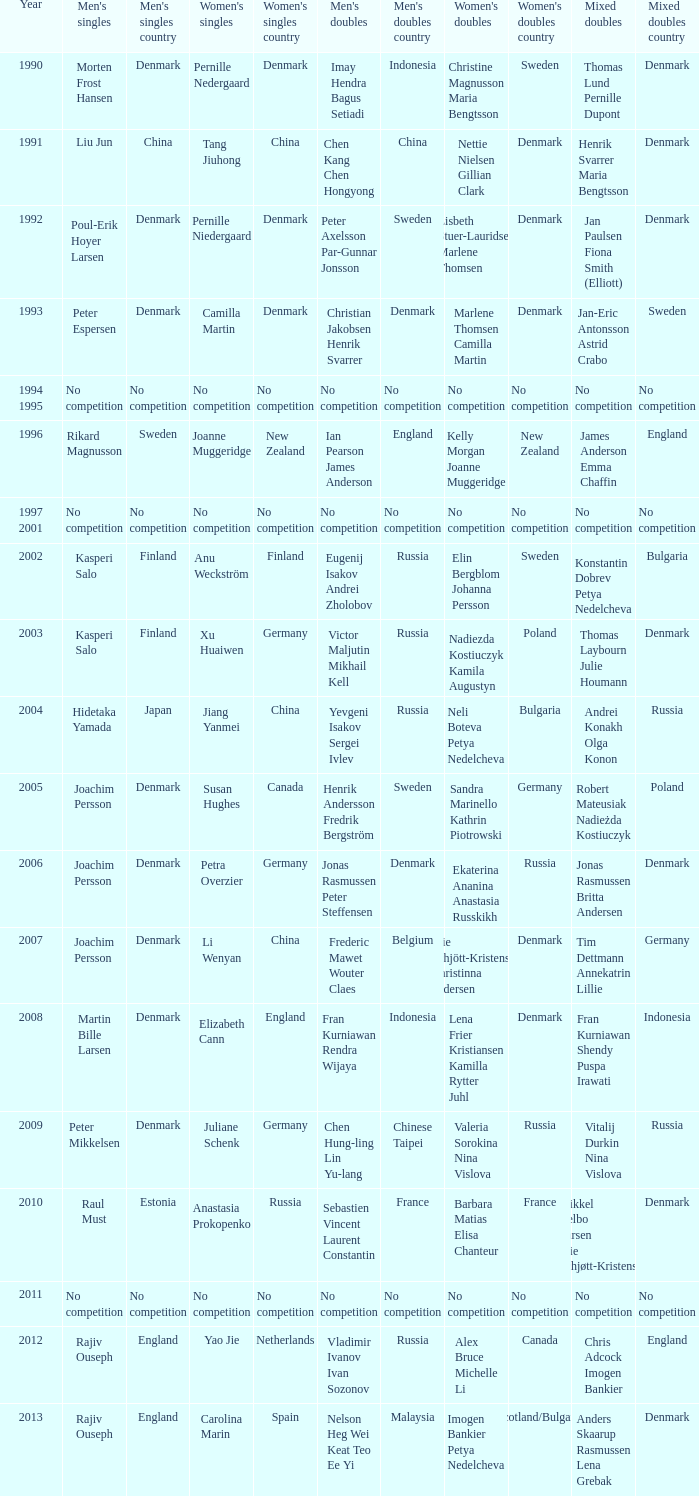Who won the Mixed doubles when Juliane Schenk won the Women's Singles? Vitalij Durkin Nina Vislova. 